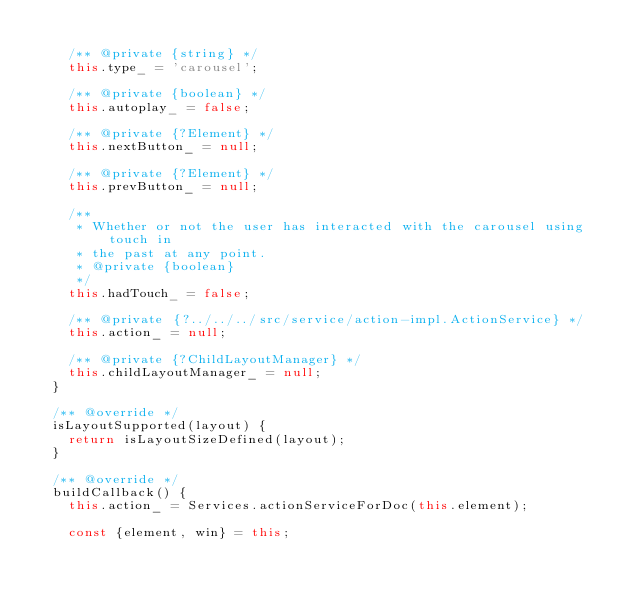Convert code to text. <code><loc_0><loc_0><loc_500><loc_500><_JavaScript_>
    /** @private {string} */
    this.type_ = 'carousel';

    /** @private {boolean} */
    this.autoplay_ = false;

    /** @private {?Element} */
    this.nextButton_ = null;

    /** @private {?Element} */
    this.prevButton_ = null;

    /**
     * Whether or not the user has interacted with the carousel using touch in
     * the past at any point.
     * @private {boolean}
     */
    this.hadTouch_ = false;

    /** @private {?../../../src/service/action-impl.ActionService} */
    this.action_ = null;

    /** @private {?ChildLayoutManager} */
    this.childLayoutManager_ = null;
  }

  /** @override */
  isLayoutSupported(layout) {
    return isLayoutSizeDefined(layout);
  }

  /** @override */
  buildCallback() {
    this.action_ = Services.actionServiceForDoc(this.element);

    const {element, win} = this;</code> 